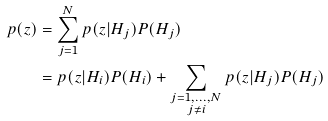<formula> <loc_0><loc_0><loc_500><loc_500>p ( z ) & = \sum _ { j = 1 } ^ { N } p ( z | H _ { j } ) P ( H _ { j } ) \\ & = p ( z | H _ { i } ) P ( H _ { i } ) + \sum _ { \substack { { j = 1 , \dots , N } \\ { j \neq i } } } p ( z | H _ { j } ) P ( H _ { j } )</formula> 